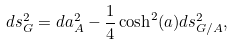<formula> <loc_0><loc_0><loc_500><loc_500>d s ^ { 2 } _ { G } = d a _ { A } ^ { 2 } - \frac { 1 } { 4 } \cosh ^ { 2 } ( a ) d s ^ { 2 } _ { G / A } ,</formula> 